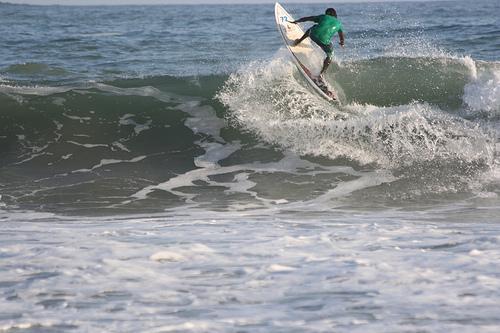How many surfboards are there?
Give a very brief answer. 1. 